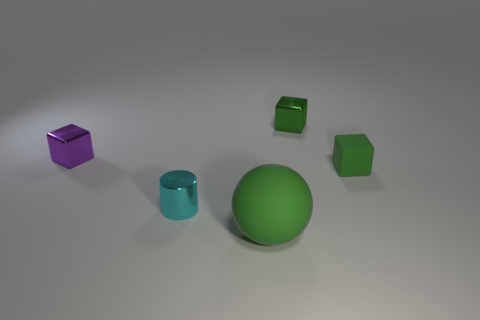How many things are either purple metal blocks or big cyan rubber objects?
Your response must be concise. 1. How big is the green block that is in front of the purple cube?
Offer a very short reply. Small. What number of green cubes are behind the cube in front of the metal cube left of the green matte ball?
Give a very brief answer. 1. Do the rubber sphere and the small cylinder have the same color?
Offer a very short reply. No. What number of green things are in front of the tiny purple thing and behind the cylinder?
Ensure brevity in your answer.  1. There is a metal thing that is in front of the purple object; what shape is it?
Keep it short and to the point. Cylinder. Is the number of big matte spheres on the left side of the cyan metallic cylinder less than the number of blocks that are to the left of the green rubber ball?
Your response must be concise. Yes. Is the cube on the left side of the metallic cylinder made of the same material as the green thing that is in front of the tiny cyan metal cylinder?
Give a very brief answer. No. The purple metal thing is what shape?
Keep it short and to the point. Cube. Are there more big matte spheres that are right of the large green matte ball than tiny cyan shiny things that are in front of the tiny cyan metal object?
Your answer should be compact. No. 